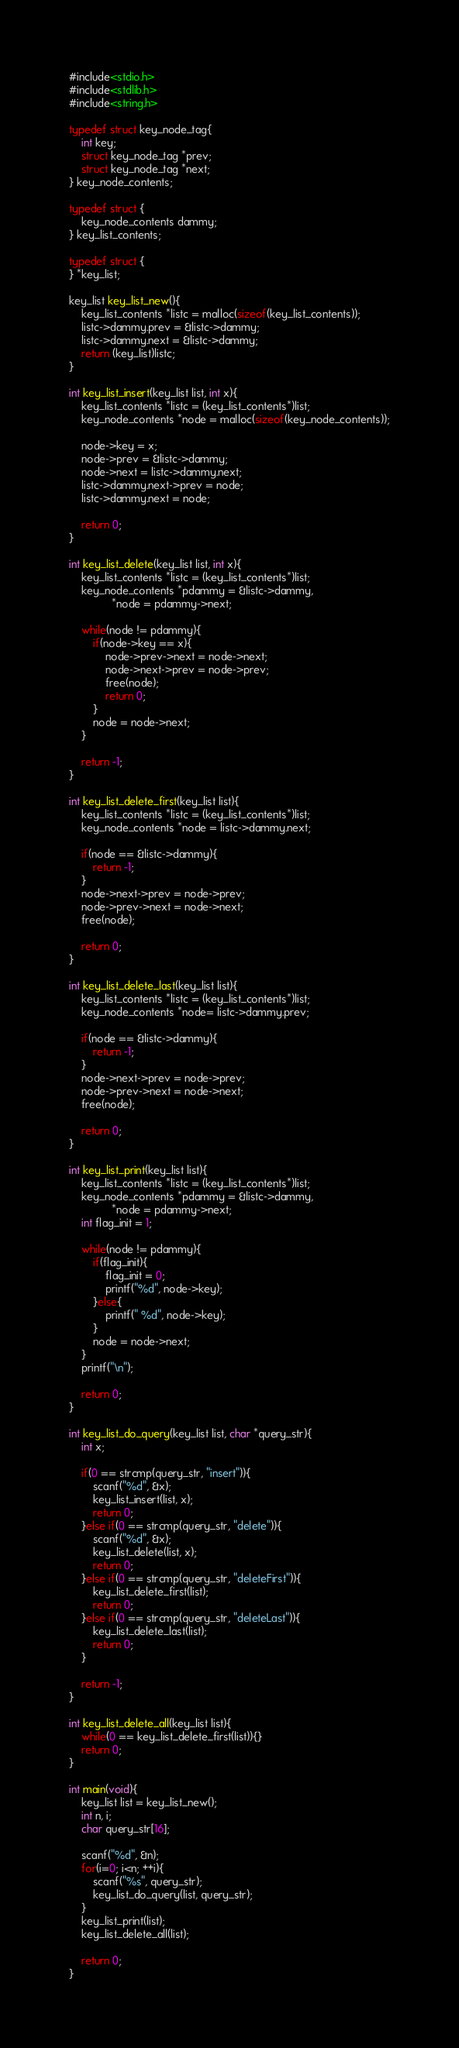<code> <loc_0><loc_0><loc_500><loc_500><_C_>#include<stdio.h>
#include<stdlib.h>
#include<string.h>

typedef struct key_node_tag{
	int key;
	struct key_node_tag *prev;
	struct key_node_tag *next;
} key_node_contents;

typedef struct {
	key_node_contents dammy;
} key_list_contents;

typedef struct {
} *key_list;

key_list key_list_new(){
	key_list_contents *listc = malloc(sizeof(key_list_contents));
	listc->dammy.prev = &listc->dammy;
	listc->dammy.next = &listc->dammy;
	return (key_list)listc;
}

int key_list_insert(key_list list, int x){
	key_list_contents *listc = (key_list_contents*)list;
	key_node_contents *node = malloc(sizeof(key_node_contents));

	node->key = x;
	node->prev = &listc->dammy;
	node->next = listc->dammy.next;
	listc->dammy.next->prev = node;
	listc->dammy.next = node;
	
	return 0;
}

int key_list_delete(key_list list, int x){
	key_list_contents *listc = (key_list_contents*)list;
	key_node_contents *pdammy = &listc->dammy,
			  *node = pdammy->next;
	
	while(node != pdammy){
		if(node->key == x){
			node->prev->next = node->next;
			node->next->prev = node->prev;
			free(node);
			return 0;
		}
		node = node->next;
	}
	
	return -1;
}

int key_list_delete_first(key_list list){
	key_list_contents *listc = (key_list_contents*)list;
	key_node_contents *node = listc->dammy.next;

	if(node == &listc->dammy){
		return -1;
	}
	node->next->prev = node->prev;
	node->prev->next = node->next;
	free(node);

	return 0;
}

int key_list_delete_last(key_list list){
	key_list_contents *listc = (key_list_contents*)list;
	key_node_contents *node= listc->dammy.prev;

	if(node == &listc->dammy){
		return -1;
	}
	node->next->prev = node->prev;
	node->prev->next = node->next;
	free(node);

	return 0;
}

int key_list_print(key_list list){
	key_list_contents *listc = (key_list_contents*)list;
	key_node_contents *pdammy = &listc->dammy,
			  *node = pdammy->next;
	int flag_init = 1;

	while(node != pdammy){
		if(flag_init){
			flag_init = 0;
			printf("%d", node->key);
		}else{
			printf(" %d", node->key);
		}
		node = node->next;
	}
	printf("\n");

	return 0;
}

int key_list_do_query(key_list list, char *query_str){
	int x;

	if(0 == strcmp(query_str, "insert")){
		scanf("%d", &x);
		key_list_insert(list, x);
		return 0;
	}else if(0 == strcmp(query_str, "delete")){
		scanf("%d", &x);
		key_list_delete(list, x);
		return 0;
	}else if(0 == strcmp(query_str, "deleteFirst")){
		key_list_delete_first(list);
		return 0;
	}else if(0 == strcmp(query_str, "deleteLast")){
		key_list_delete_last(list);
		return 0;
	}

	return -1;
}

int key_list_delete_all(key_list list){
	while(0 == key_list_delete_first(list)){}
	return 0;
}

int main(void){
	key_list list = key_list_new();
	int n, i;
	char query_str[16];

	scanf("%d", &n);
	for(i=0; i<n; ++i){
		scanf("%s", query_str);
		key_list_do_query(list, query_str);
	}
	key_list_print(list);
	key_list_delete_all(list);

	return 0;
}</code> 